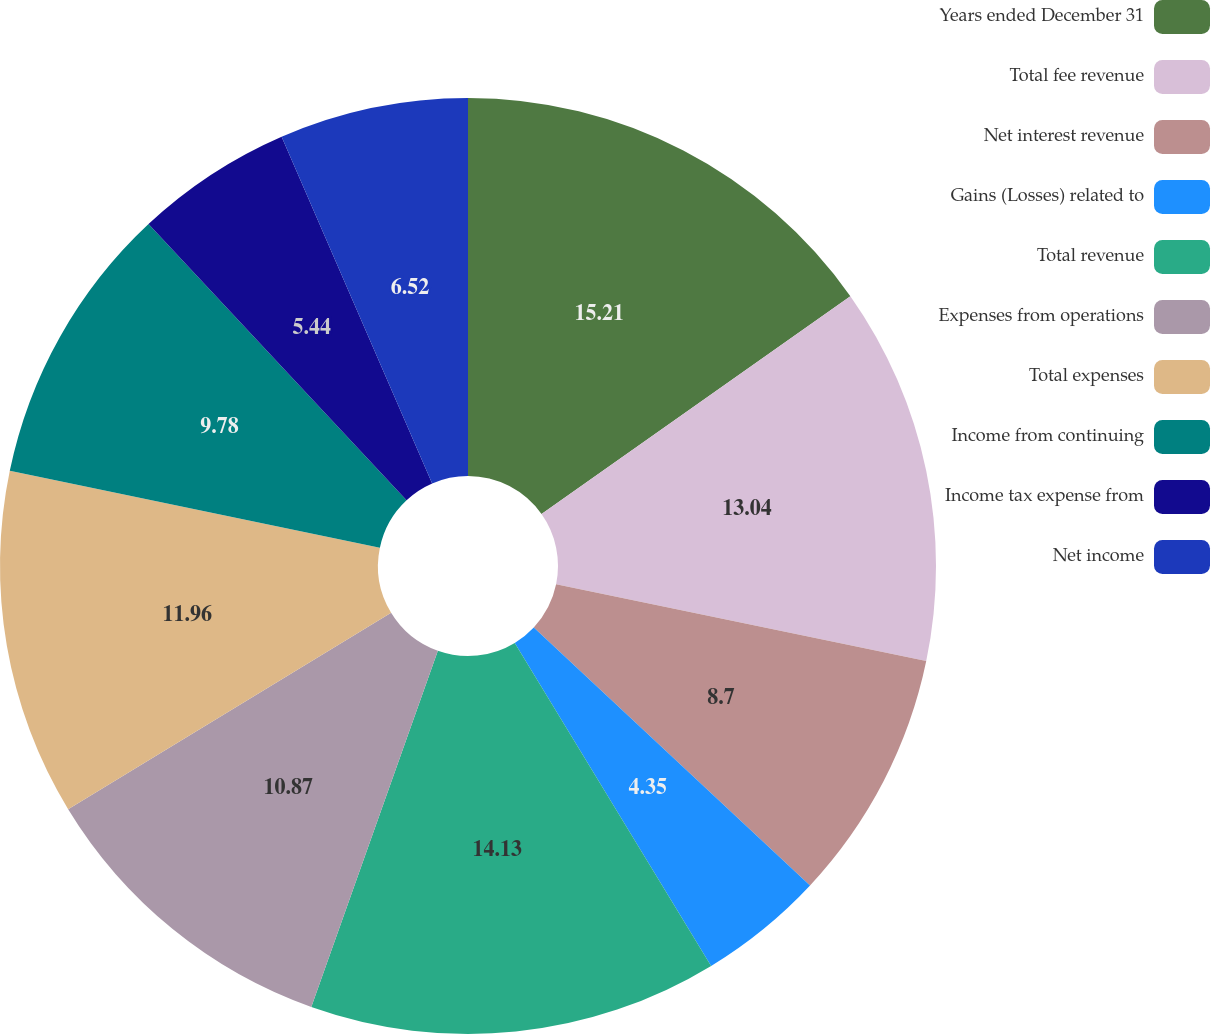Convert chart. <chart><loc_0><loc_0><loc_500><loc_500><pie_chart><fcel>Years ended December 31<fcel>Total fee revenue<fcel>Net interest revenue<fcel>Gains (Losses) related to<fcel>Total revenue<fcel>Expenses from operations<fcel>Total expenses<fcel>Income from continuing<fcel>Income tax expense from<fcel>Net income<nl><fcel>15.22%<fcel>13.04%<fcel>8.7%<fcel>4.35%<fcel>14.13%<fcel>10.87%<fcel>11.96%<fcel>9.78%<fcel>5.44%<fcel>6.52%<nl></chart> 